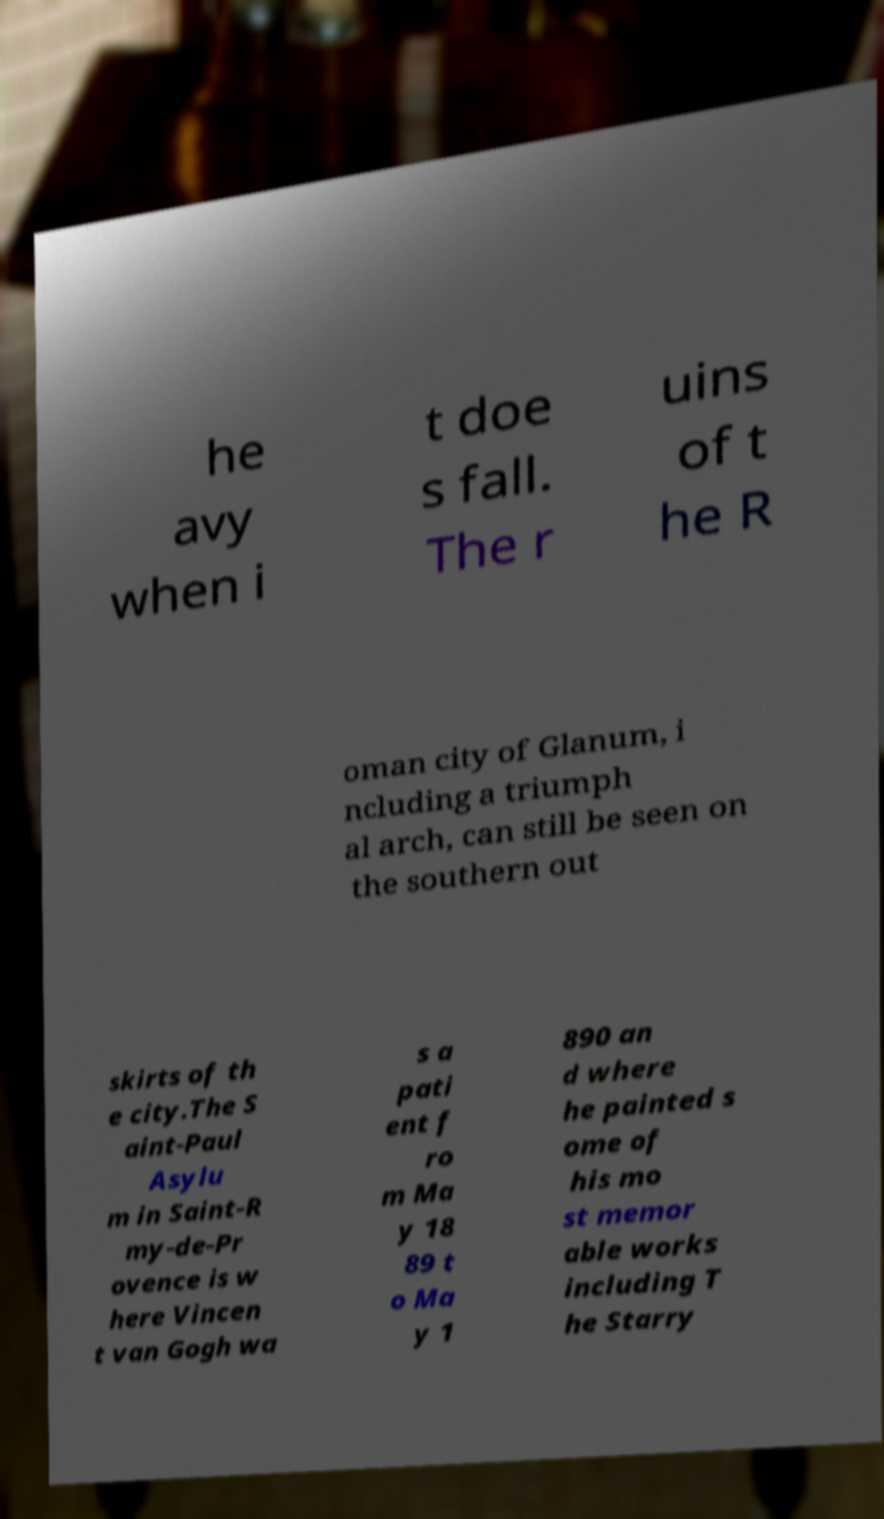For documentation purposes, I need the text within this image transcribed. Could you provide that? he avy when i t doe s fall. The r uins of t he R oman city of Glanum, i ncluding a triumph al arch, can still be seen on the southern out skirts of th e city.The S aint-Paul Asylu m in Saint-R my-de-Pr ovence is w here Vincen t van Gogh wa s a pati ent f ro m Ma y 18 89 t o Ma y 1 890 an d where he painted s ome of his mo st memor able works including T he Starry 